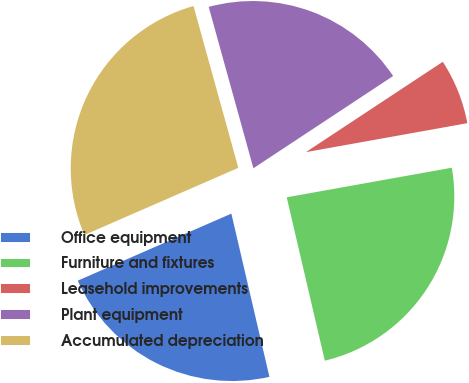Convert chart. <chart><loc_0><loc_0><loc_500><loc_500><pie_chart><fcel>Office equipment<fcel>Furniture and fixtures<fcel>Leasehold improvements<fcel>Plant equipment<fcel>Accumulated depreciation<nl><fcel>22.1%<fcel>24.18%<fcel>6.46%<fcel>20.02%<fcel>27.25%<nl></chart> 